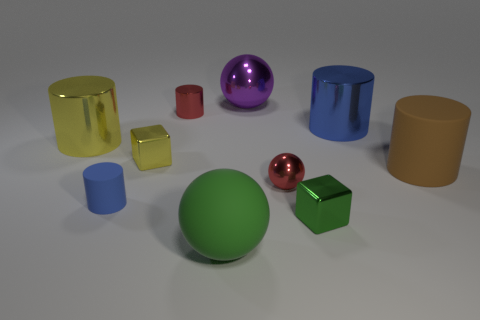Subtract all yellow cylinders. How many cylinders are left? 4 Subtract all big brown cylinders. How many cylinders are left? 4 Subtract all gray cylinders. Subtract all green blocks. How many cylinders are left? 5 Subtract all balls. How many objects are left? 7 Add 4 matte spheres. How many matte spheres are left? 5 Add 5 blue metal cylinders. How many blue metal cylinders exist? 6 Subtract 0 gray spheres. How many objects are left? 10 Subtract all small shiny things. Subtract all small yellow metallic objects. How many objects are left? 5 